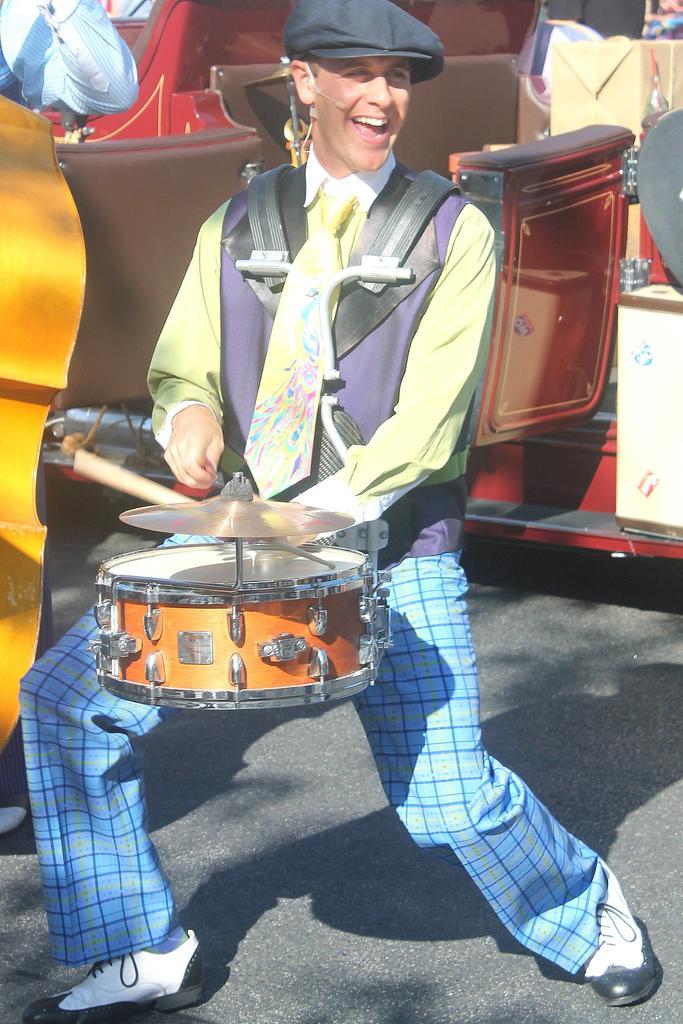How would you summarize this image in a sentence or two? In this image we can see a man is playing musical instrument. In the background there is a vehicle and a box and on the left side there is a musical instrument and a person's hand. 